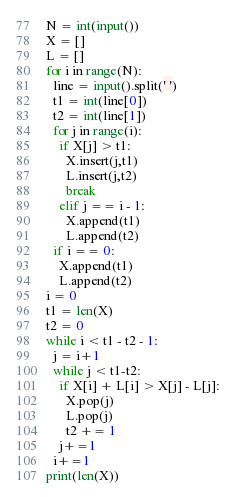Convert code to text. <code><loc_0><loc_0><loc_500><loc_500><_Python_>N = int(input())
X = []
L = []
for i in range(N):
  line = input().split(' ')
  t1 = int(line[0])
  t2 = int(line[1])
  for j in range(i):
    if X[j] > t1:
      X.insert(j,t1)
      L.insert(j,t2)
      break
    elif j == i - 1:
      X.append(t1)
      L.append(t2)
  if i == 0:
    X.append(t1)
    L.append(t2)
i = 0
t1 = len(X)
t2 = 0
while i < t1 - t2 - 1:
  j = i+1
  while j < t1-t2:
    if X[i] + L[i] > X[j] - L[j]:
      X.pop(j)
      L.pop(j)
      t2 += 1
    j+=1
  i+=1
print(len(X))</code> 